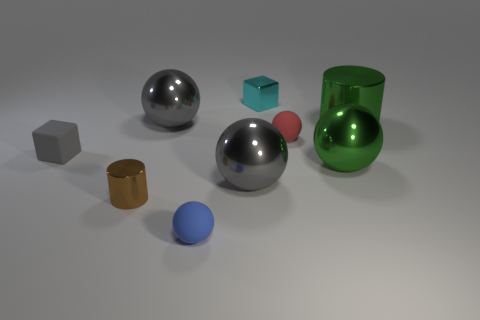What is the color of the largest sphere and what is on its immediate right? The largest sphere is silver-colored, and immediately to its right is a smaller blue sphere. Both are resting on the surface. What can you tell me about the lighting in this scene? The lighting in the scene appears soft and diffused, creating gentle shadows and soft reflections on the objects, suggesting an indoor environment with a possibly overcast daylight or soft artificial light. 